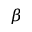<formula> <loc_0><loc_0><loc_500><loc_500>\beta</formula> 